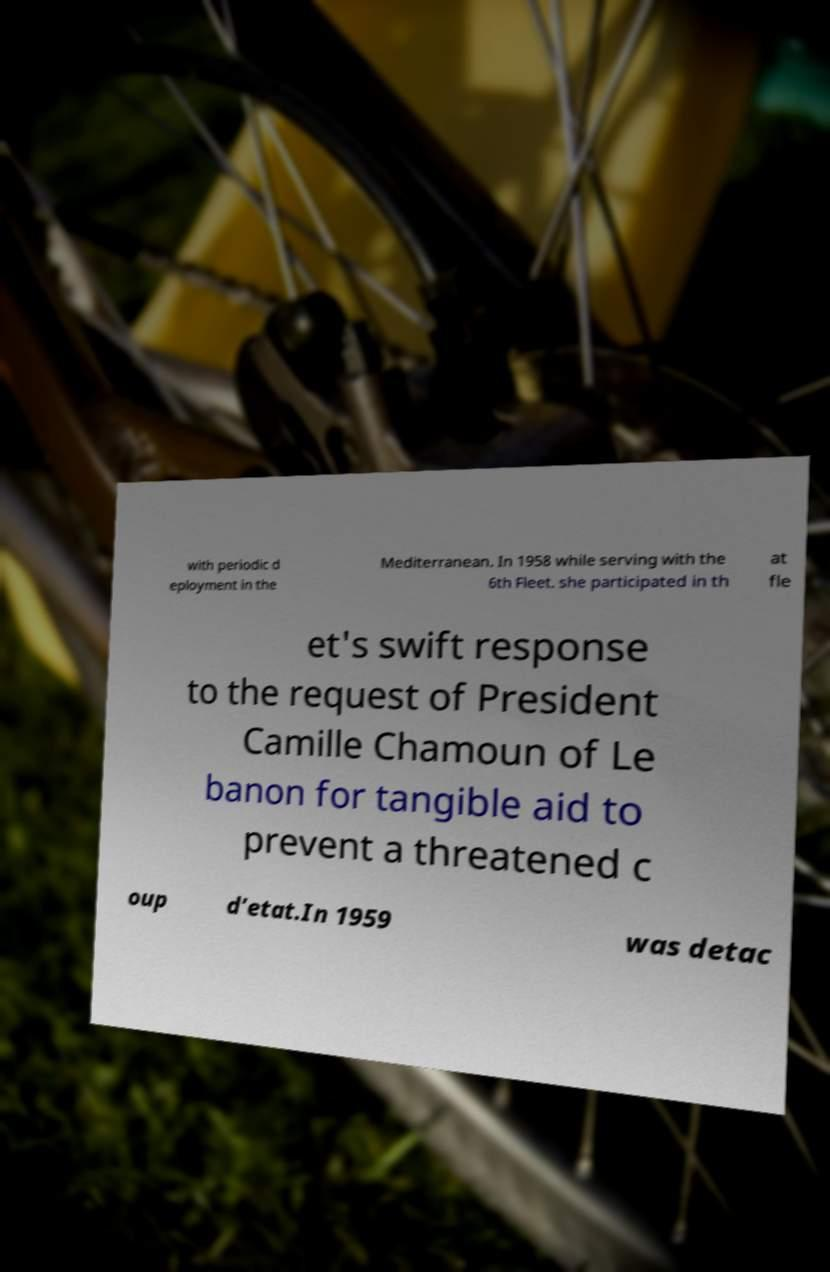I need the written content from this picture converted into text. Can you do that? with periodic d eployment in the Mediterranean. In 1958 while serving with the 6th Fleet. she participated in th at fle et's swift response to the request of President Camille Chamoun of Le banon for tangible aid to prevent a threatened c oup d’etat.In 1959 was detac 